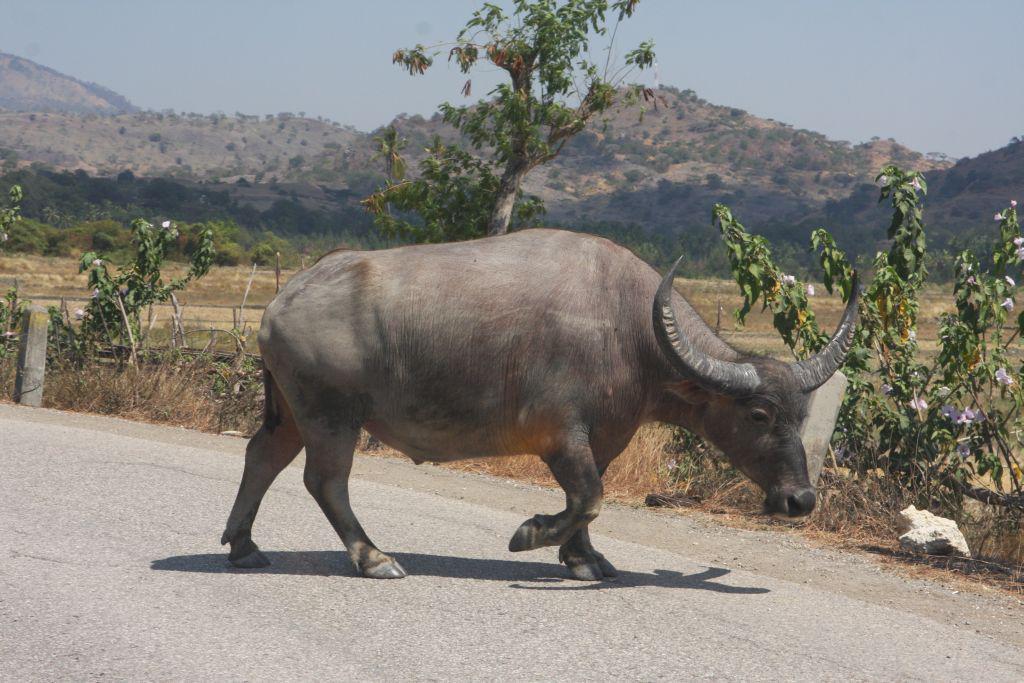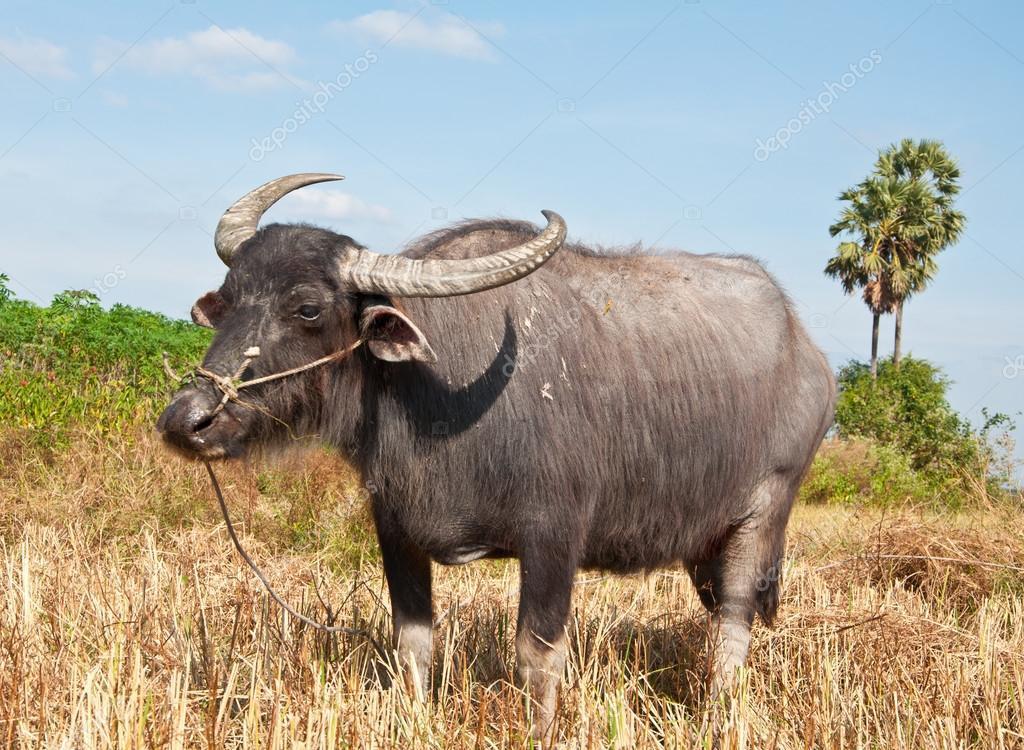The first image is the image on the left, the second image is the image on the right. Considering the images on both sides, is "The cow in the image on the right is near a watery area." valid? Answer yes or no. No. 